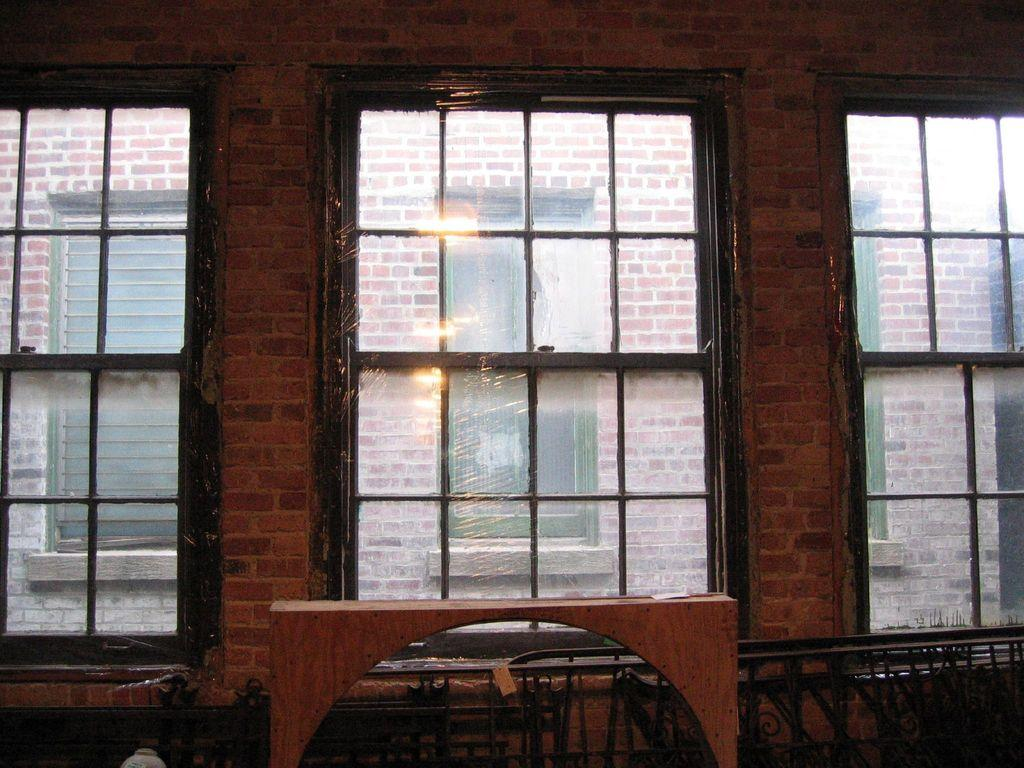What can be seen outside the windows in the image? There is a building visible through the windows in the image. What type of structure is present in the image? There is an iron grill in the image. How many credits are visible on the iron grill in the image? There are no credits present on the iron grill in the image. What type of animal can be seen hopping around near the iron grill in the image? There are no animals, including rabbits, present in the image. 